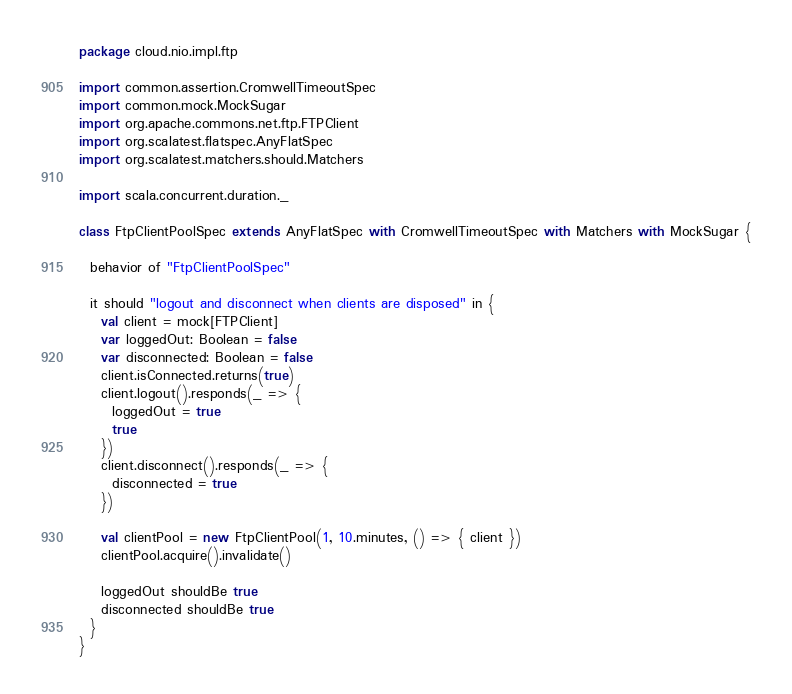Convert code to text. <code><loc_0><loc_0><loc_500><loc_500><_Scala_>package cloud.nio.impl.ftp

import common.assertion.CromwellTimeoutSpec
import common.mock.MockSugar
import org.apache.commons.net.ftp.FTPClient
import org.scalatest.flatspec.AnyFlatSpec
import org.scalatest.matchers.should.Matchers

import scala.concurrent.duration._

class FtpClientPoolSpec extends AnyFlatSpec with CromwellTimeoutSpec with Matchers with MockSugar {

  behavior of "FtpClientPoolSpec"

  it should "logout and disconnect when clients are disposed" in {
    val client = mock[FTPClient]
    var loggedOut: Boolean = false
    var disconnected: Boolean = false
    client.isConnected.returns(true)
    client.logout().responds(_ => {
      loggedOut = true
      true
    })
    client.disconnect().responds(_ => {
      disconnected = true
    })

    val clientPool = new FtpClientPool(1, 10.minutes, () => { client })
    clientPool.acquire().invalidate()

    loggedOut shouldBe true
    disconnected shouldBe true
  }
}
</code> 